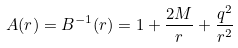Convert formula to latex. <formula><loc_0><loc_0><loc_500><loc_500>A ( r ) = B ^ { - 1 } ( r ) = 1 + \frac { 2 M } { r } + \frac { q ^ { 2 } } { r ^ { 2 } }</formula> 